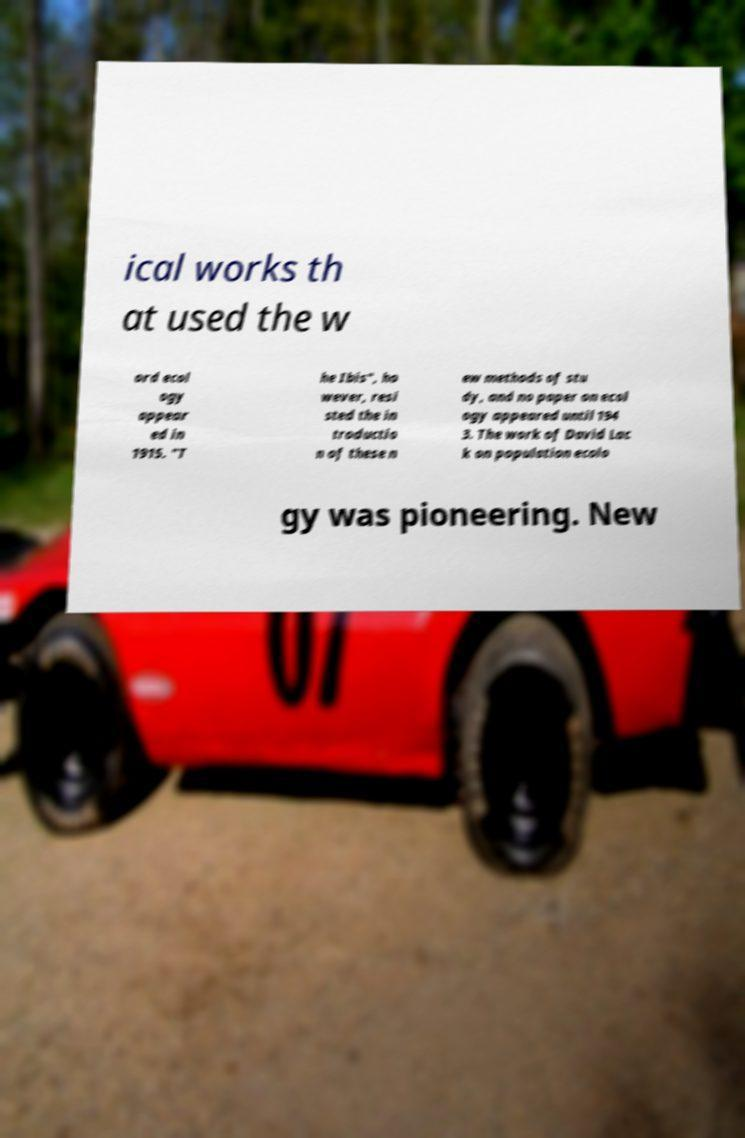There's text embedded in this image that I need extracted. Can you transcribe it verbatim? ical works th at used the w ord ecol ogy appear ed in 1915. "T he Ibis", ho wever, resi sted the in troductio n of these n ew methods of stu dy, and no paper on ecol ogy appeared until 194 3. The work of David Lac k on population ecolo gy was pioneering. New 